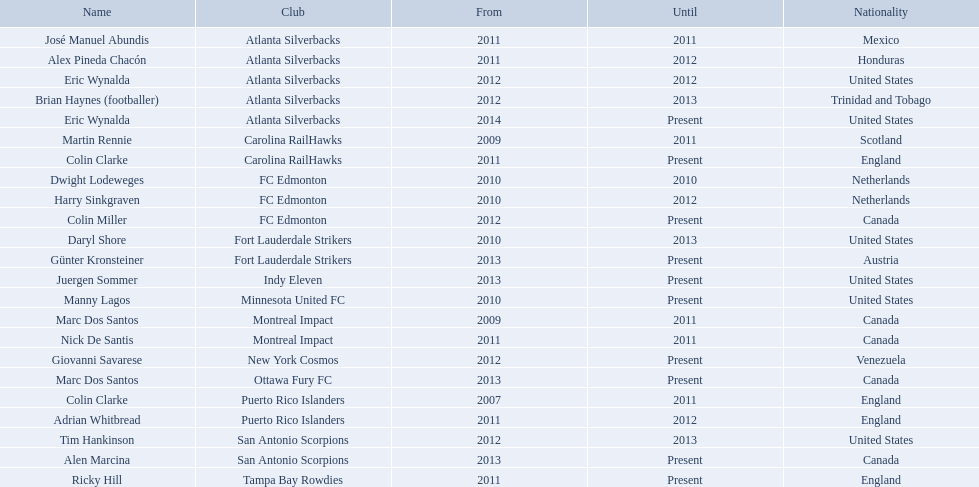What were all the coaches who were coaching in 2010? Martin Rennie, Dwight Lodeweges, Harry Sinkgraven, Daryl Shore, Manny Lagos, Marc Dos Santos, Colin Clarke. Which of the 2010 coaches were not born in north america? Martin Rennie, Dwight Lodeweges, Harry Sinkgraven, Colin Clarke. Which coaches that were coaching in 2010 and were not from north america did not coach for fc edmonton? Martin Rennie, Colin Clarke. What coach did not coach for fc edmonton in 2010 and was not north american nationality had the shortened career as a coach? Martin Rennie. What year did marc dos santos start as coach? 2009. Which other starting years correspond with this year? 2009. Who was the other coach with this starting year Martin Rennie. 